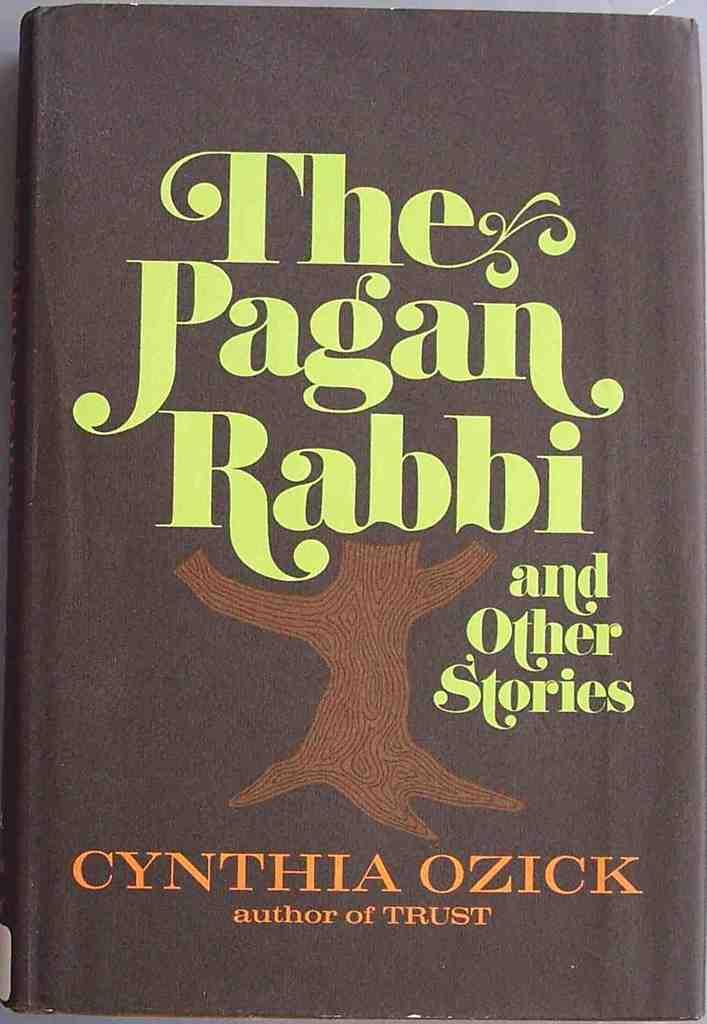What is the title of the book?
Your response must be concise. The pagan rabbi. Is this a book of short stories?
Keep it short and to the point. Yes. 